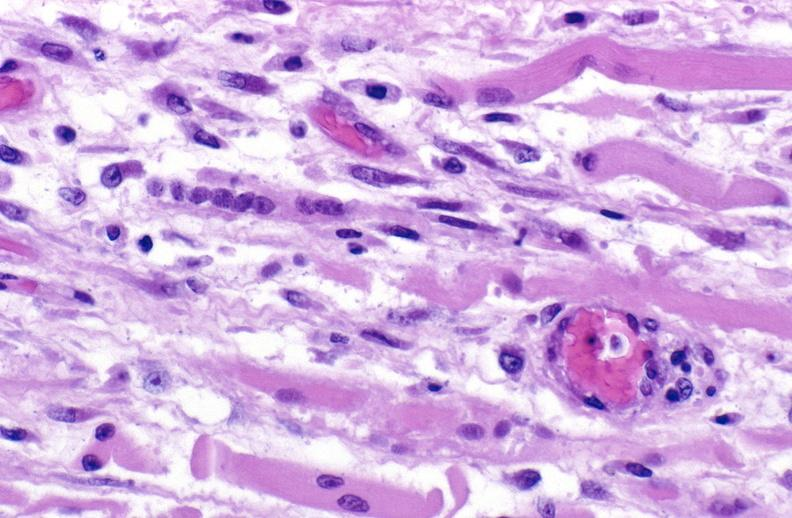s rheumatoid arthritis present?
Answer the question using a single word or phrase. No 